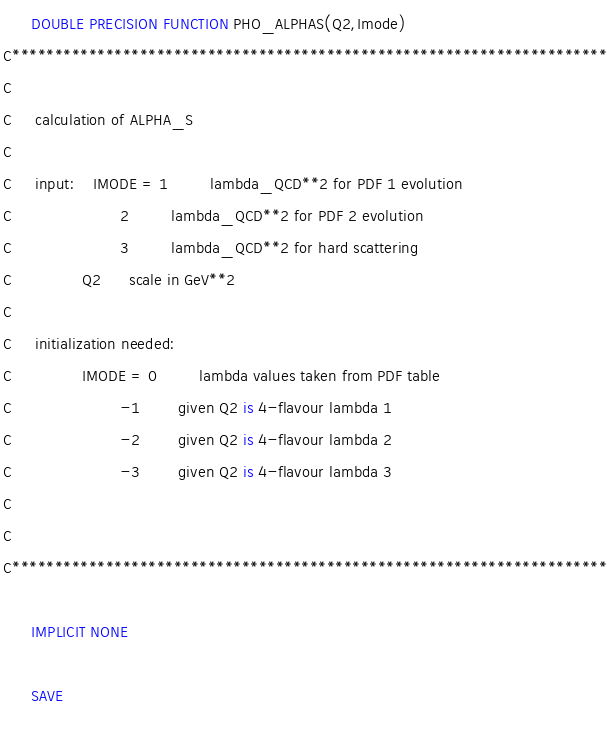Convert code to text. <code><loc_0><loc_0><loc_500><loc_500><_FORTRAN_>      DOUBLE PRECISION FUNCTION PHO_ALPHAS(Q2,Imode)
C**********************************************************************
C
C     calculation of ALPHA_S
C
C     input:    IMODE = 1         lambda_QCD**2 for PDF 1 evolution
C                       2         lambda_QCD**2 for PDF 2 evolution
C                       3         lambda_QCD**2 for hard scattering
C               Q2      scale in GeV**2
C
C     initialization needed:
C               IMODE = 0         lambda values taken from PDF table
C                       -1        given Q2 is 4-flavour lambda 1
C                       -2        given Q2 is 4-flavour lambda 2
C                       -3        given Q2 is 4-flavour lambda 3
C
C
C**********************************************************************
 
      IMPLICIT NONE
 
      SAVE 
 </code> 